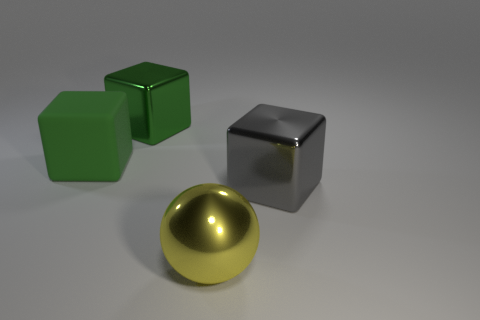How many rubber blocks are the same color as the big metallic sphere?
Your answer should be compact. 0. There is a shiny sphere; is it the same size as the metallic object left of the yellow metal sphere?
Make the answer very short. Yes. How big is the metal object that is in front of the big metal cube in front of the block that is behind the green matte object?
Your response must be concise. Large. How many yellow things are behind the gray shiny block?
Provide a short and direct response. 0. There is a cube on the right side of the big metal object in front of the gray metallic block; what is it made of?
Your response must be concise. Metal. Do the rubber block and the metal sphere have the same size?
Give a very brief answer. Yes. How many objects are either large shiny blocks to the left of the big yellow metal thing or metal blocks that are on the left side of the shiny ball?
Offer a terse response. 1. Is the number of metal objects behind the large rubber thing greater than the number of big yellow blocks?
Give a very brief answer. Yes. What number of other things are the same shape as the big yellow shiny thing?
Offer a very short reply. 0. There is a object that is to the right of the large green metallic cube and behind the yellow shiny sphere; what material is it made of?
Your answer should be compact. Metal. 